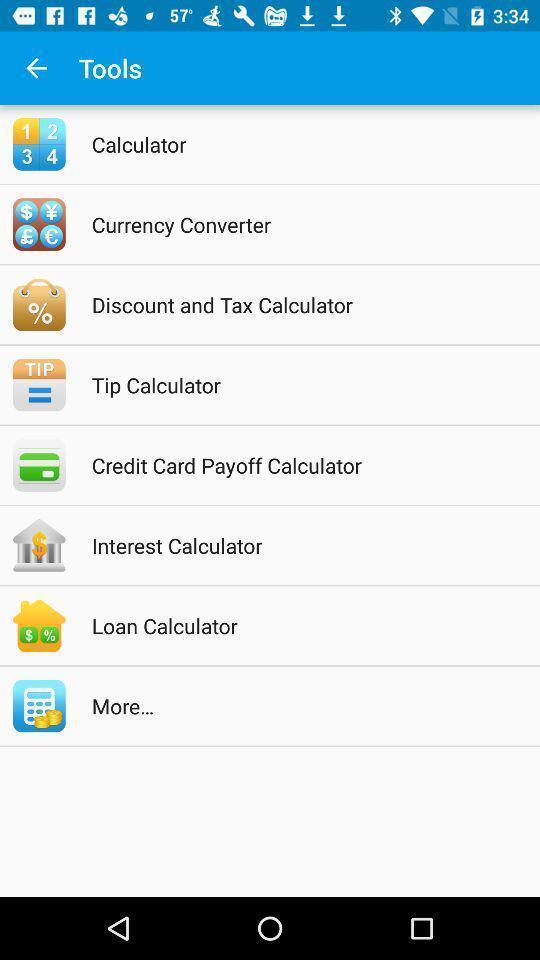Describe the visual elements of this screenshot. Screen shows different tools in a mobile. 